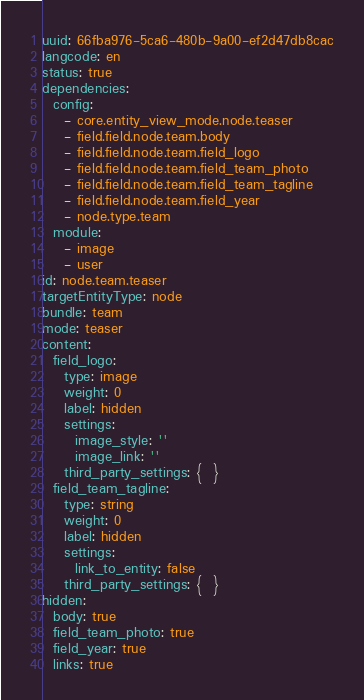Convert code to text. <code><loc_0><loc_0><loc_500><loc_500><_YAML_>uuid: 66fba976-5ca6-480b-9a00-ef2d47db8cac
langcode: en
status: true
dependencies:
  config:
    - core.entity_view_mode.node.teaser
    - field.field.node.team.body
    - field.field.node.team.field_logo
    - field.field.node.team.field_team_photo
    - field.field.node.team.field_team_tagline
    - field.field.node.team.field_year
    - node.type.team
  module:
    - image
    - user
id: node.team.teaser
targetEntityType: node
bundle: team
mode: teaser
content:
  field_logo:
    type: image
    weight: 0
    label: hidden
    settings:
      image_style: ''
      image_link: ''
    third_party_settings: {  }
  field_team_tagline:
    type: string
    weight: 0
    label: hidden
    settings:
      link_to_entity: false
    third_party_settings: {  }
hidden:
  body: true
  field_team_photo: true
  field_year: true
  links: true
</code> 